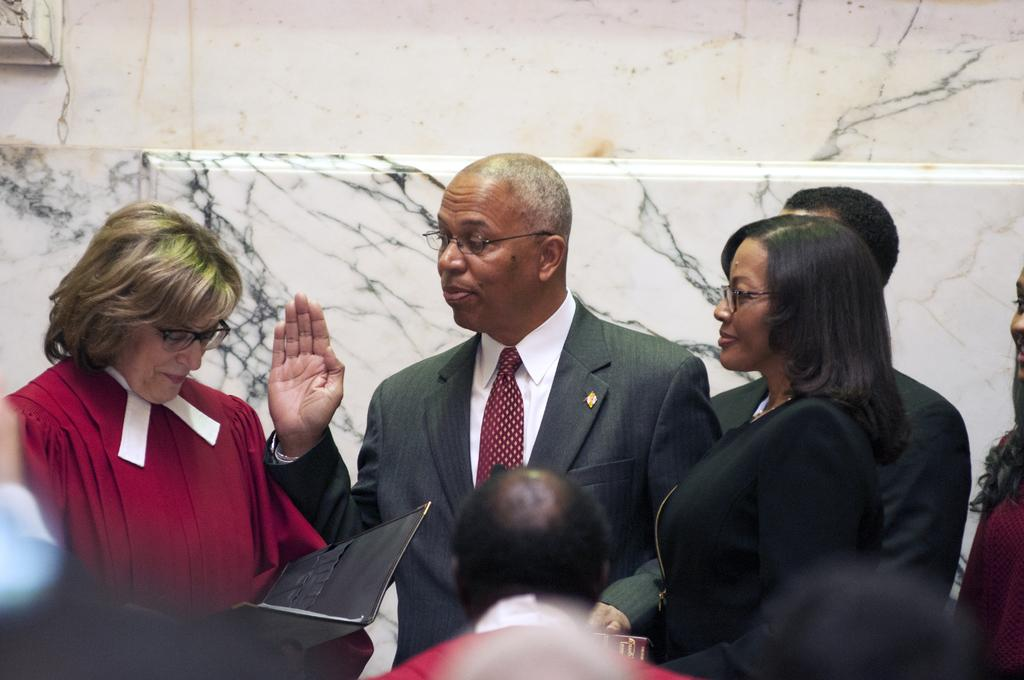How many people are in the image? There is a group of persons standing in the image, but the exact number is not specified. What is the woman holding in the image? There is a woman holding an object in the image, but the specific object is not described. What can be seen in the background of the image? There is a wall in the background of the image. What type of substance is being ordered by the group of persons in the image? There is no indication in the image that the group of persons is ordering any substance. What type of engine is visible in the image? There is no engine present in the image. 